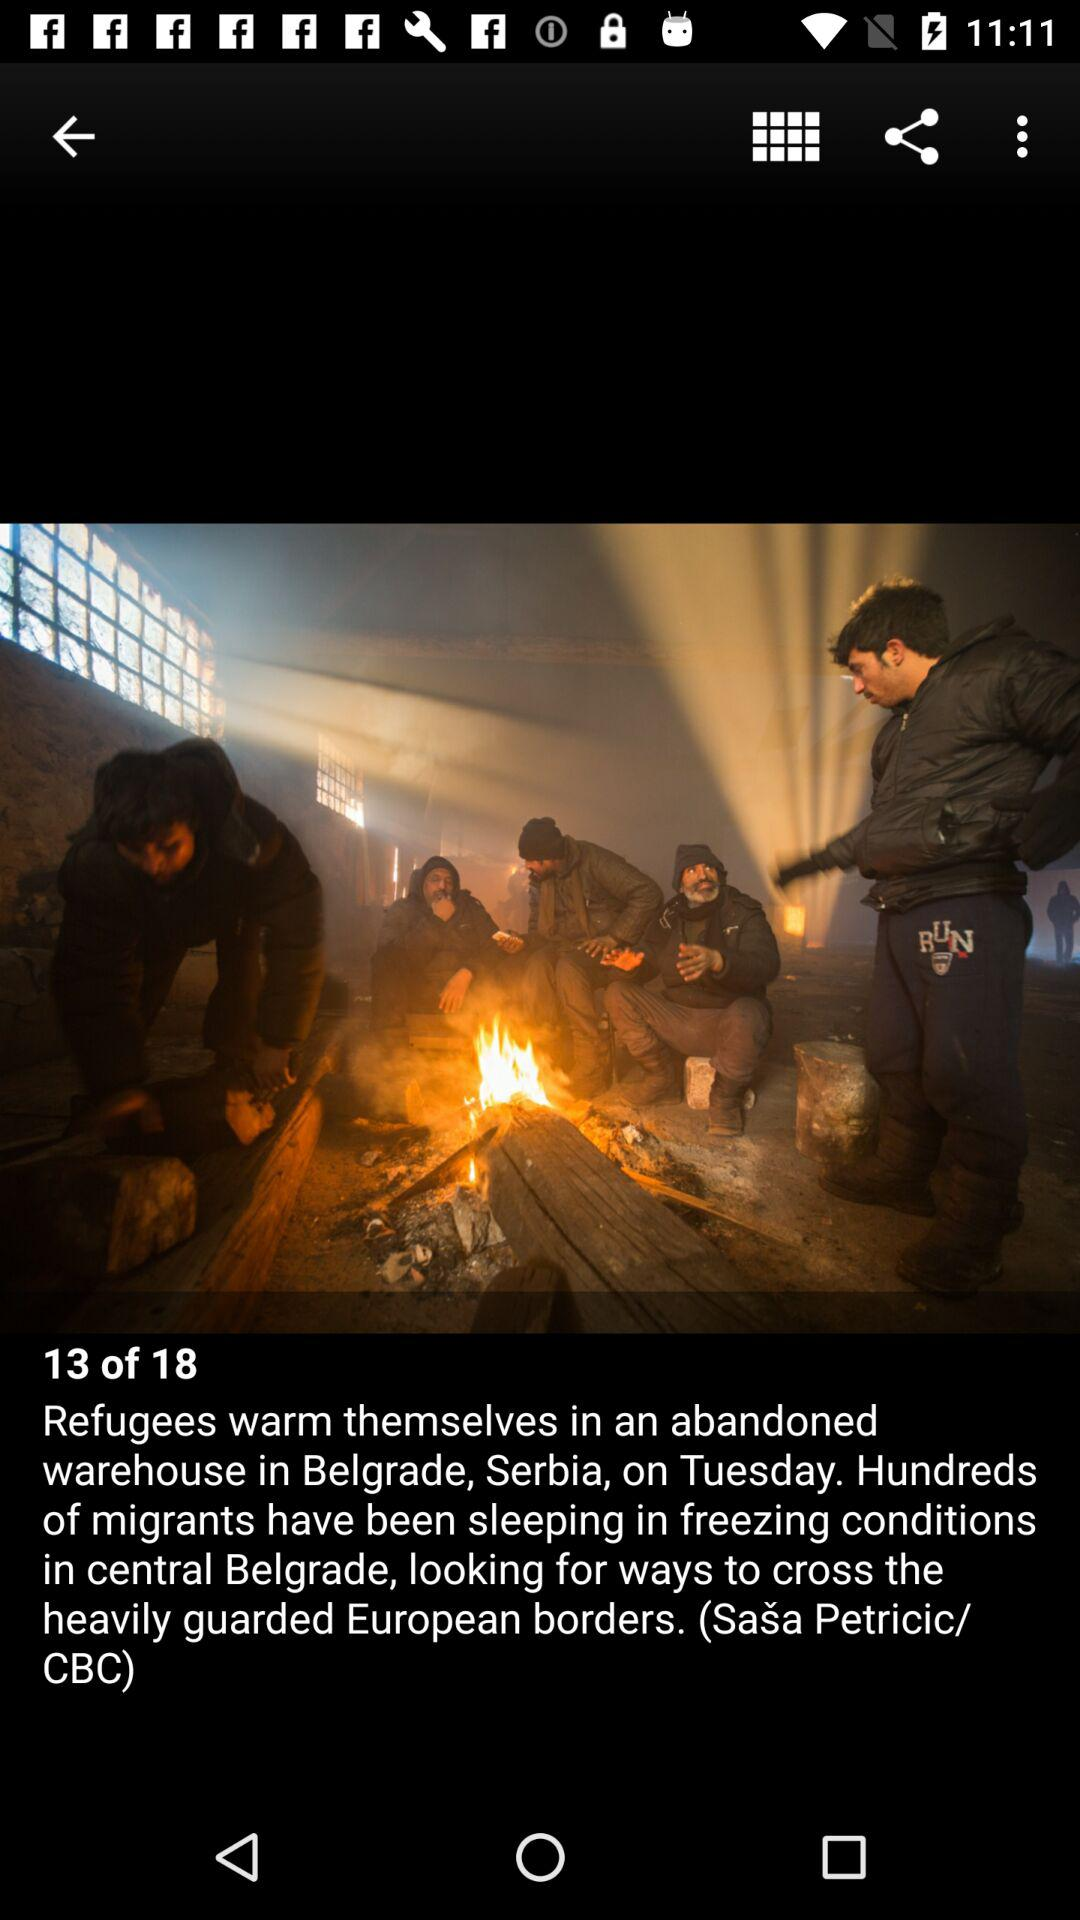What is the total number of pages in the article? The total number of pages is 18. 